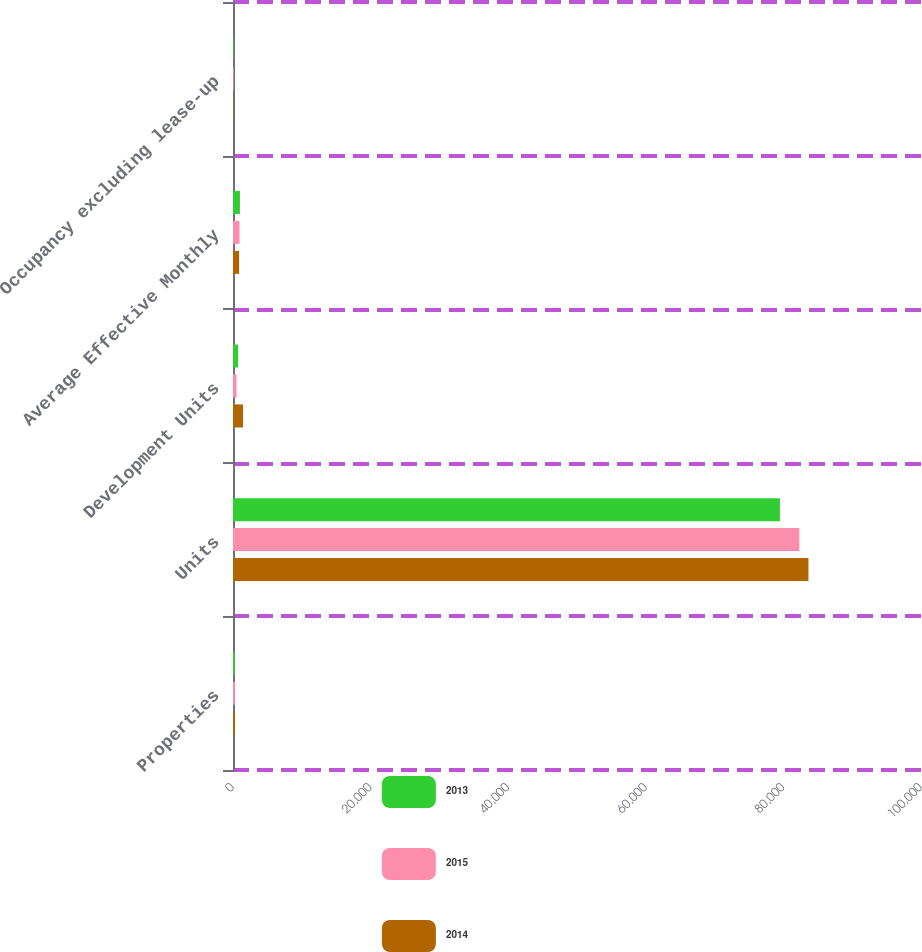<chart> <loc_0><loc_0><loc_500><loc_500><stacked_bar_chart><ecel><fcel>Properties<fcel>Units<fcel>Development Units<fcel>Average Effective Monthly<fcel>Occupancy excluding lease-up<nl><fcel>2013<fcel>254<fcel>79496<fcel>748<fcel>1006<fcel>95.6<nl><fcel>2015<fcel>268<fcel>82316<fcel>514<fcel>948<fcel>94.1<nl><fcel>2014<fcel>275<fcel>83641<fcel>1461<fcel>883<fcel>94.9<nl></chart> 